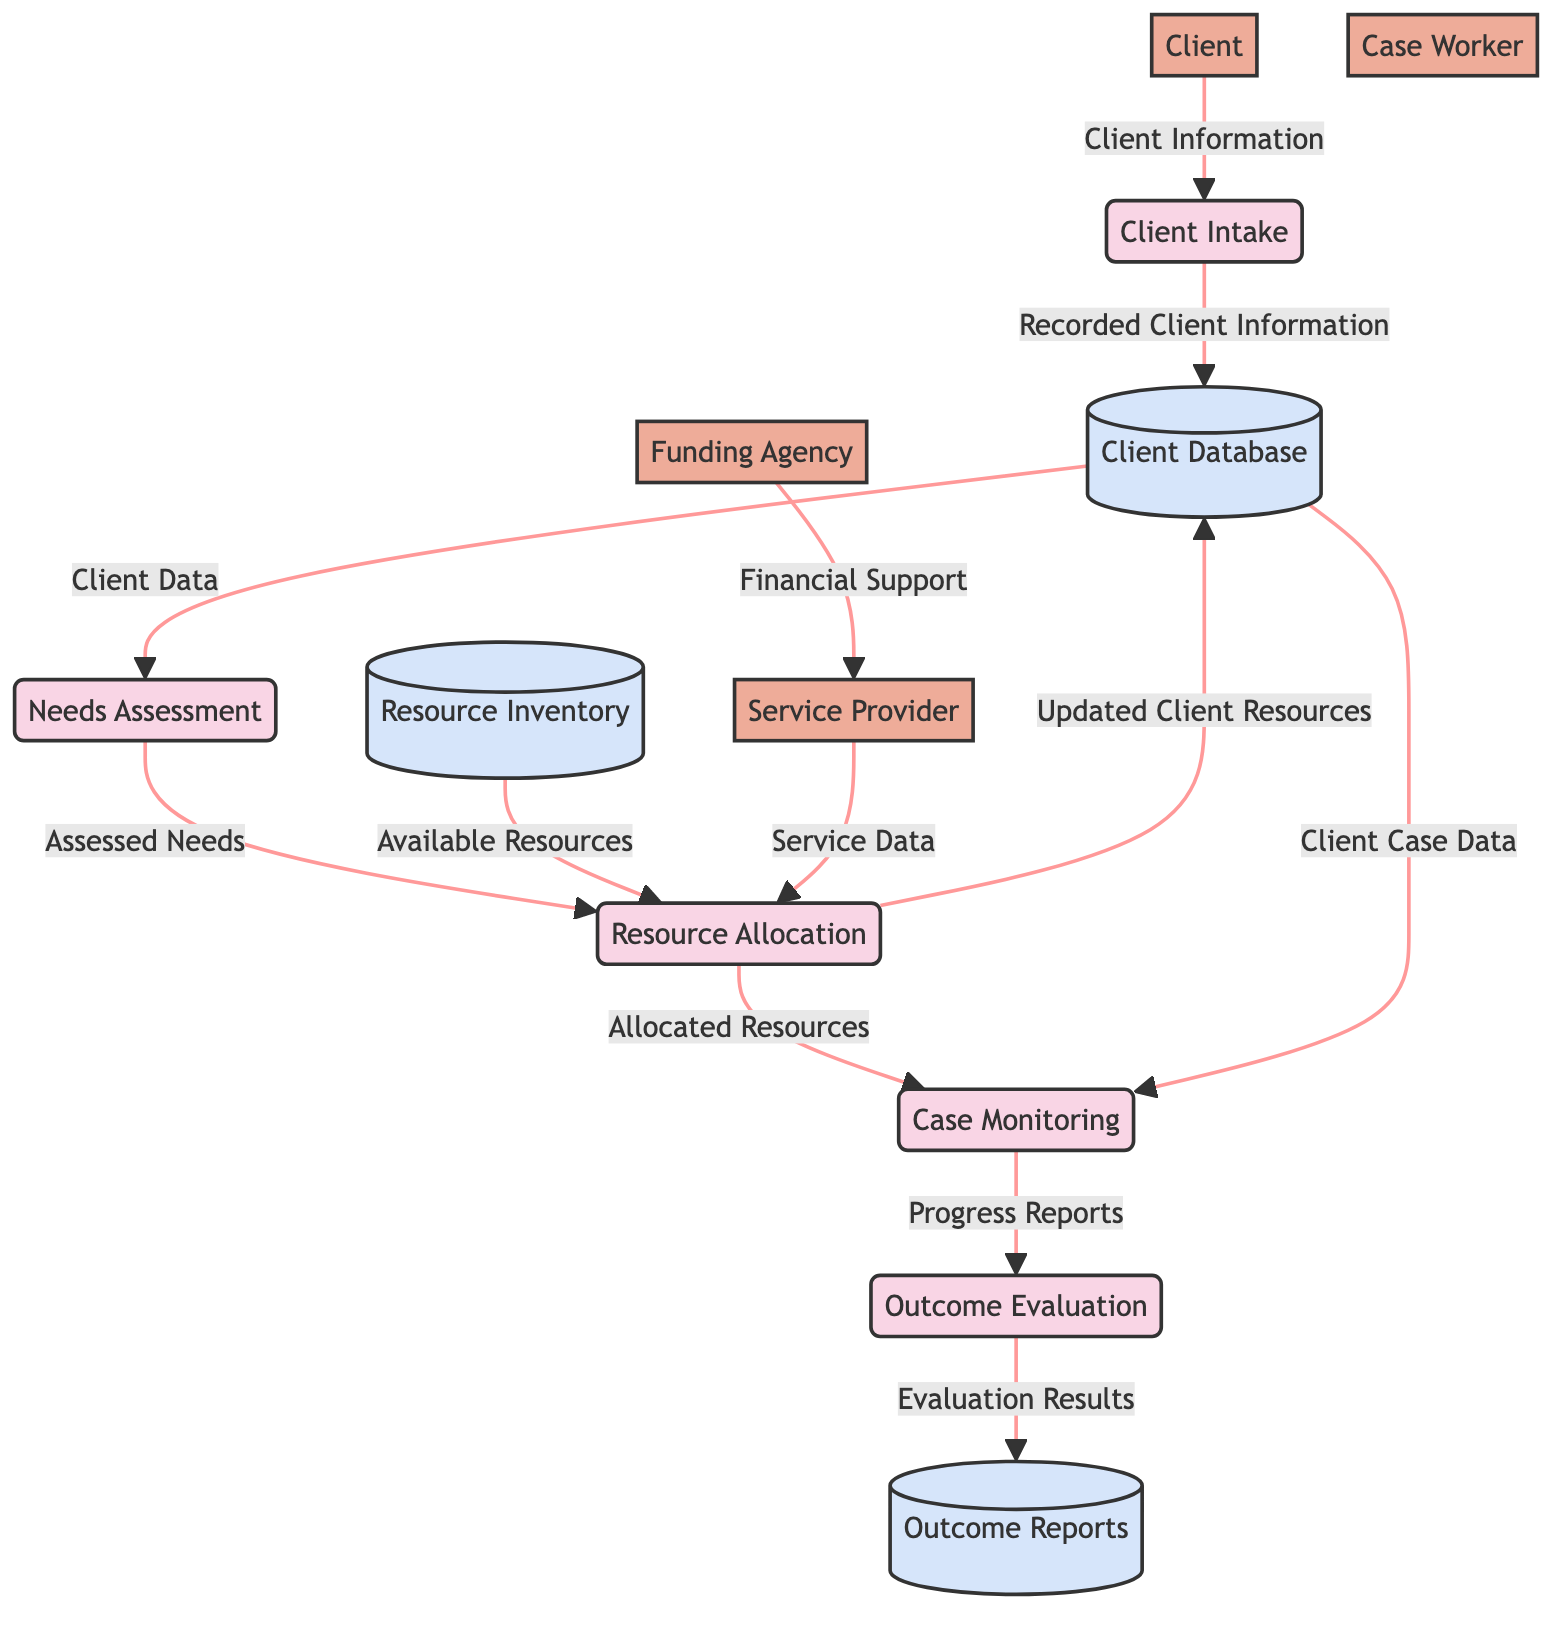What is the first process in the diagram? The first process in the diagram is "Client Intake," which is where initial client data collection and assessment occurs.
Answer: Client Intake What entity is responsible for managing the client's case? The "Case Worker" entity is the one designated to manage the client's case as shown in the diagram.
Answer: Case Worker How many processes are in the diagram? There are five processes as listed in the diagram, including Client Intake, Needs Assessment, Resource Allocation, Case Monitoring, and Outcome Evaluation.
Answer: 5 What type of data flows from the Needs Assessment to Resource Allocation? The flow from Needs Assessment to Resource Allocation consists of "Assessed Needs", which indicates a logical progression in the case management process.
Answer: Assessed Needs What data is stored in the "Outcome Reports"? "Outcome Reports" contain "Evaluation Results" pertaining to the effectiveness of resource allocation and client progress within the system.
Answer: Evaluation Results Which entity provides financial support? The "Funding Agency" is the entity that provides financial support as indicated in the data flows of the diagram.
Answer: Funding Agency Which two processes output data to the client database? The two processes that output data to the client database are "Client Intake" and "Resource Allocation", both of which update records in the client database.
Answer: Client Intake, Resource Allocation What is the relationship between Case Monitoring and Outcome Evaluation? The relationship is that "Progress Reports" flow from Case Monitoring to Outcome Evaluation, indicating ongoing assessment of client progress.
Answer: Progress Reports What information does the Resource Inventory provide to Resource Allocation? The Resource Inventory provides "Available Resources" to the Resource Allocation process, which is necessary for assigning resources to clients.
Answer: Available Resources 